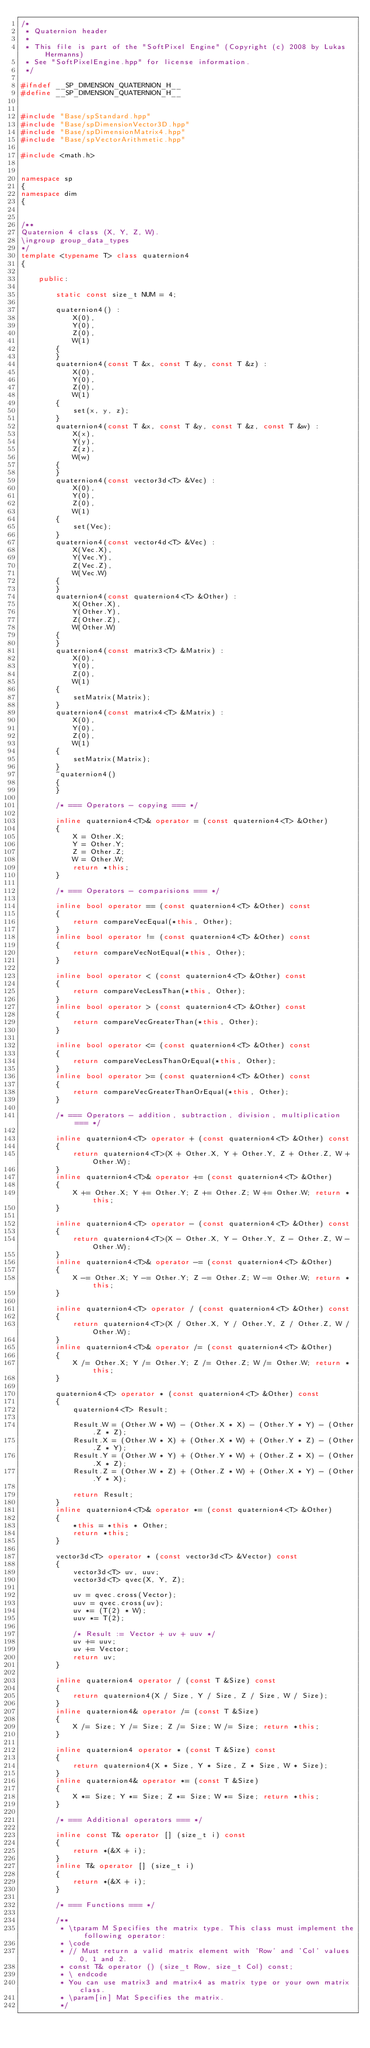Convert code to text. <code><loc_0><loc_0><loc_500><loc_500><_C++_>/*
 * Quaternion header
 * 
 * This file is part of the "SoftPixel Engine" (Copyright (c) 2008 by Lukas Hermanns)
 * See "SoftPixelEngine.hpp" for license information.
 */

#ifndef __SP_DIMENSION_QUATERNION_H__
#define __SP_DIMENSION_QUATERNION_H__


#include "Base/spStandard.hpp"
#include "Base/spDimensionVector3D.hpp"
#include "Base/spDimensionMatrix4.hpp"
#include "Base/spVectorArithmetic.hpp"

#include <math.h>


namespace sp
{
namespace dim
{


/**
Quaternion 4 class (X, Y, Z, W).
\ingroup group_data_types
*/
template <typename T> class quaternion4
{
    
    public:
        
        static const size_t NUM = 4;
        
        quaternion4() :
            X(0),
            Y(0),
            Z(0),
            W(1)
        {
        }
        quaternion4(const T &x, const T &y, const T &z) :
            X(0),
            Y(0),
            Z(0),
            W(1)
        {
            set(x, y, z);
        }
        quaternion4(const T &x, const T &y, const T &z, const T &w) :
            X(x),
            Y(y),
            Z(z),
            W(w)
        {
        }
        quaternion4(const vector3d<T> &Vec) :
            X(0),
            Y(0),
            Z(0),
            W(1)
        {
            set(Vec);
        }
        quaternion4(const vector4d<T> &Vec) :
            X(Vec.X),
            Y(Vec.Y),
            Z(Vec.Z),
            W(Vec.W)
        {
        }
        quaternion4(const quaternion4<T> &Other) :
            X(Other.X),
            Y(Other.Y),
            Z(Other.Z),
            W(Other.W)
        {
        }
        quaternion4(const matrix3<T> &Matrix) :
            X(0),
            Y(0),
            Z(0),
            W(1)
        {
            setMatrix(Matrix);
        }
        quaternion4(const matrix4<T> &Matrix) :
            X(0),
            Y(0),
            Z(0),
            W(1)
        {
            setMatrix(Matrix);
        }
        ~quaternion4()
        {
        }
        
        /* === Operators - copying === */
        
        inline quaternion4<T>& operator = (const quaternion4<T> &Other)
        {
            X = Other.X;
            Y = Other.Y;
            Z = Other.Z;
            W = Other.W;
            return *this;
        }
        
        /* === Operators - comparisions === */
        
        inline bool operator == (const quaternion4<T> &Other) const
        {
            return compareVecEqual(*this, Other);
        }
        inline bool operator != (const quaternion4<T> &Other) const
        {
            return compareVecNotEqual(*this, Other);
        }
        
        inline bool operator < (const quaternion4<T> &Other) const
        {
            return compareVecLessThan(*this, Other);
        }
        inline bool operator > (const quaternion4<T> &Other) const
        {
            return compareVecGreaterThan(*this, Other);
        }
        
        inline bool operator <= (const quaternion4<T> &Other) const
        {
            return compareVecLessThanOrEqual(*this, Other);
        }
        inline bool operator >= (const quaternion4<T> &Other) const
        {
            return compareVecGreaterThanOrEqual(*this, Other);
        }
        
        /* === Operators - addition, subtraction, division, multiplication === */
        
        inline quaternion4<T> operator + (const quaternion4<T> &Other) const
        {
            return quaternion4<T>(X + Other.X, Y + Other.Y, Z + Other.Z, W + Other.W);
        }
        inline quaternion4<T>& operator += (const quaternion4<T> &Other)
        {
            X += Other.X; Y += Other.Y; Z += Other.Z; W += Other.W; return *this;
        }
        
        inline quaternion4<T> operator - (const quaternion4<T> &Other) const
        {
            return quaternion4<T>(X - Other.X, Y - Other.Y, Z - Other.Z, W - Other.W);
        }
        inline quaternion4<T>& operator -= (const quaternion4<T> &Other)
        {
            X -= Other.X; Y -= Other.Y; Z -= Other.Z; W -= Other.W; return *this;
        }
        
        inline quaternion4<T> operator / (const quaternion4<T> &Other) const
        {
            return quaternion4<T>(X / Other.X, Y / Other.Y, Z / Other.Z, W / Other.W);
        }
        inline quaternion4<T>& operator /= (const quaternion4<T> &Other)
        {
            X /= Other.X; Y /= Other.Y; Z /= Other.Z; W /= Other.W; return *this;
        }
        
        quaternion4<T> operator * (const quaternion4<T> &Other) const
        {
            quaternion4<T> Result;
            
            Result.W = (Other.W * W) - (Other.X * X) - (Other.Y * Y) - (Other.Z * Z);
            Result.X = (Other.W * X) + (Other.X * W) + (Other.Y * Z) - (Other.Z * Y);
            Result.Y = (Other.W * Y) + (Other.Y * W) + (Other.Z * X) - (Other.X * Z);
            Result.Z = (Other.W * Z) + (Other.Z * W) + (Other.X * Y) - (Other.Y * X);
            
            return Result;
        }
        inline quaternion4<T>& operator *= (const quaternion4<T> &Other)
        {
            *this = *this * Other;
            return *this;
        }
        
        vector3d<T> operator * (const vector3d<T> &Vector) const
        {
            vector3d<T> uv, uuv;
            vector3d<T> qvec(X, Y, Z);
            
            uv = qvec.cross(Vector);
            uuv = qvec.cross(uv);
            uv *= (T(2) * W);
            uuv *= T(2);
            
            /* Result := Vector + uv + uuv */
            uv += uuv;
            uv += Vector;
            return uv;
        }
        
        inline quaternion4 operator / (const T &Size) const
        {
            return quaternion4(X / Size, Y / Size, Z / Size, W / Size);
        }
        inline quaternion4& operator /= (const T &Size)
        {
            X /= Size; Y /= Size; Z /= Size; W /= Size; return *this;
        }
        
        inline quaternion4 operator * (const T &Size) const
        {
            return quaternion4(X * Size, Y * Size, Z * Size, W * Size);
        }
        inline quaternion4& operator *= (const T &Size)
        {
            X *= Size; Y *= Size; Z *= Size; W *= Size; return *this;
        }
        
        /* === Additional operators === */
        
        inline const T& operator [] (size_t i) const
        {
            return *(&X + i);
        }
        inline T& operator [] (size_t i)
        {
            return *(&X + i);
        }

        /* === Functions === */
        
        /**
         * \tparam M Specifies the matrix type. This class must implement the following operator:
         * \code
         * // Must return a valid matrix element with 'Row' and 'Col' values 0, 1 and 2.
         * const T& operator () (size_t Row, size_t Col) const;
         * \ endcode
         * You can use matrix3 and matrix4 as matrix type or your own matrix class.
         * \param[in] Mat Specifies the matrix.
         */</code> 